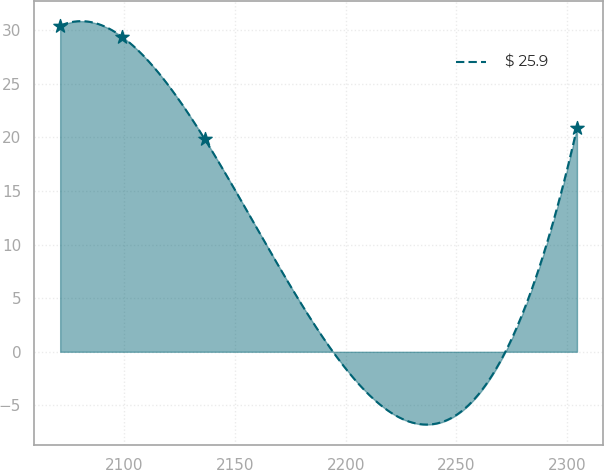<chart> <loc_0><loc_0><loc_500><loc_500><line_chart><ecel><fcel>$ 25.9<nl><fcel>2071.07<fcel>30.41<nl><fcel>2099.11<fcel>29.37<nl><fcel>2136.32<fcel>19.84<nl><fcel>2304.39<fcel>20.88<nl></chart> 